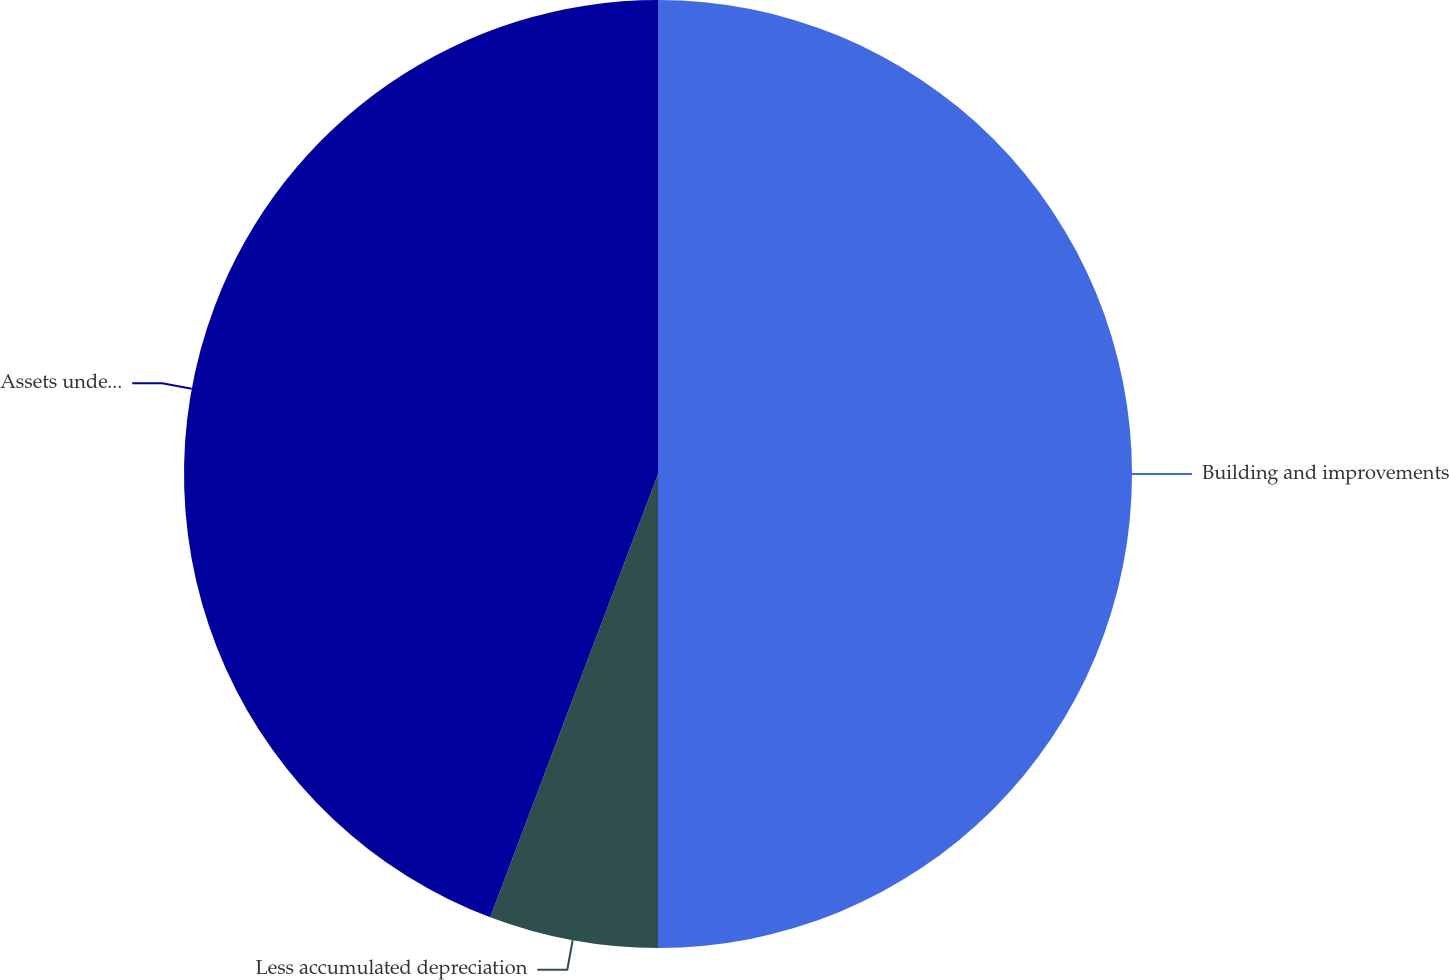Convert chart to OTSL. <chart><loc_0><loc_0><loc_500><loc_500><pie_chart><fcel>Building and improvements<fcel>Less accumulated depreciation<fcel>Assets under capital lease net<nl><fcel>50.0%<fcel>5.76%<fcel>44.24%<nl></chart> 